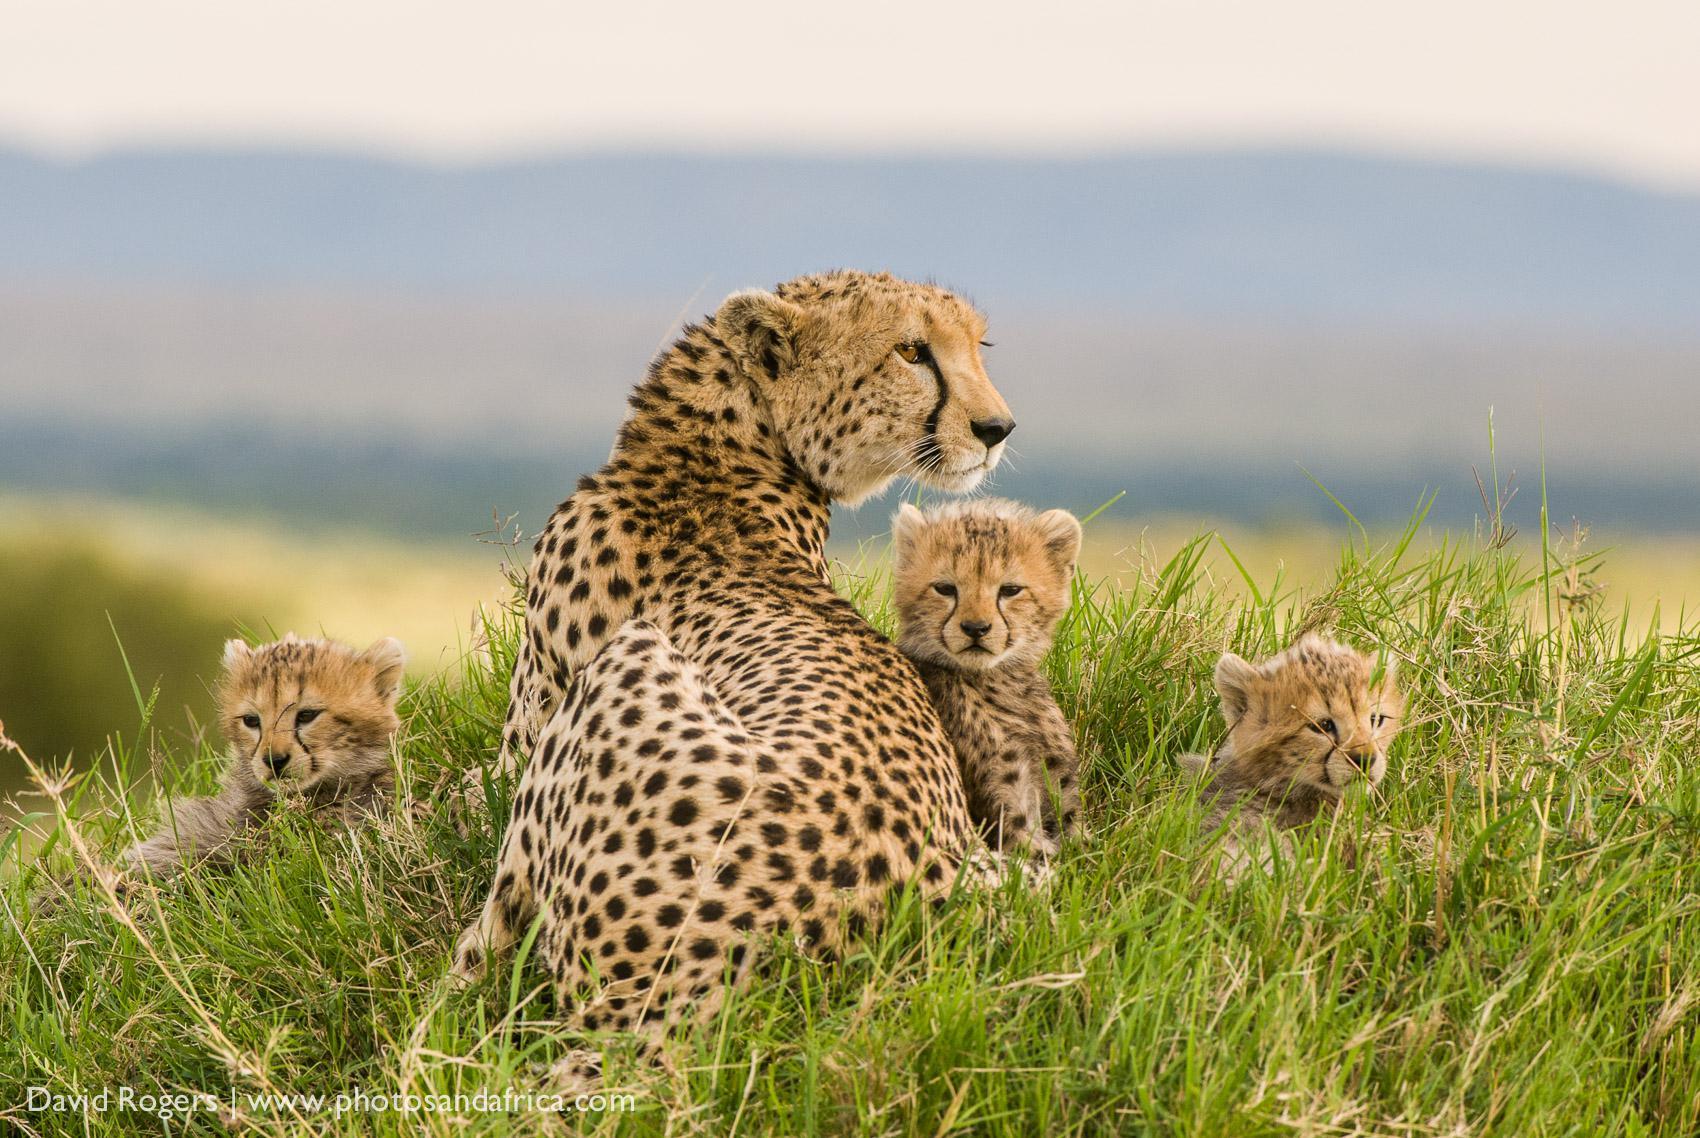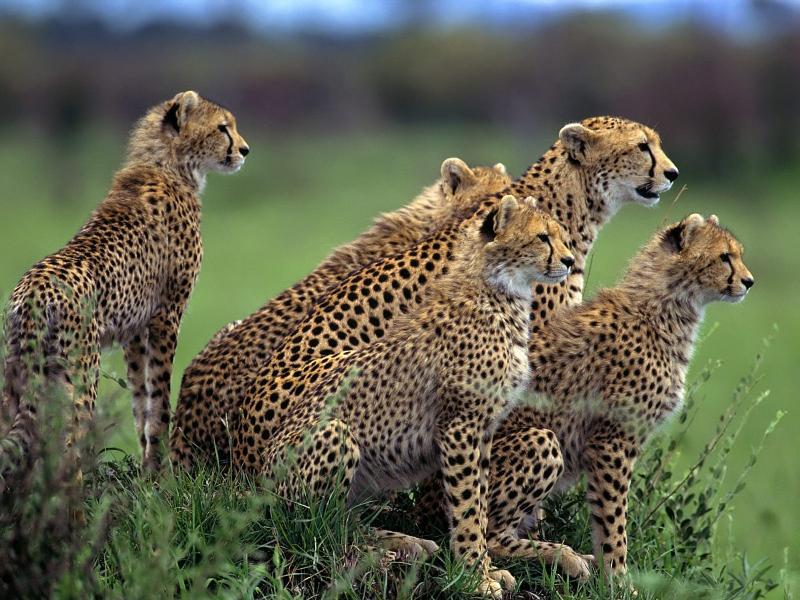The first image is the image on the left, the second image is the image on the right. Given the left and right images, does the statement "Exactly six of the big cats are resting, keeping an eye on their surroundings." hold true? Answer yes or no. No. The first image is the image on the left, the second image is the image on the right. Evaluate the accuracy of this statement regarding the images: "There are four leopard’s sitting on a mound of dirt.". Is it true? Answer yes or no. No. 